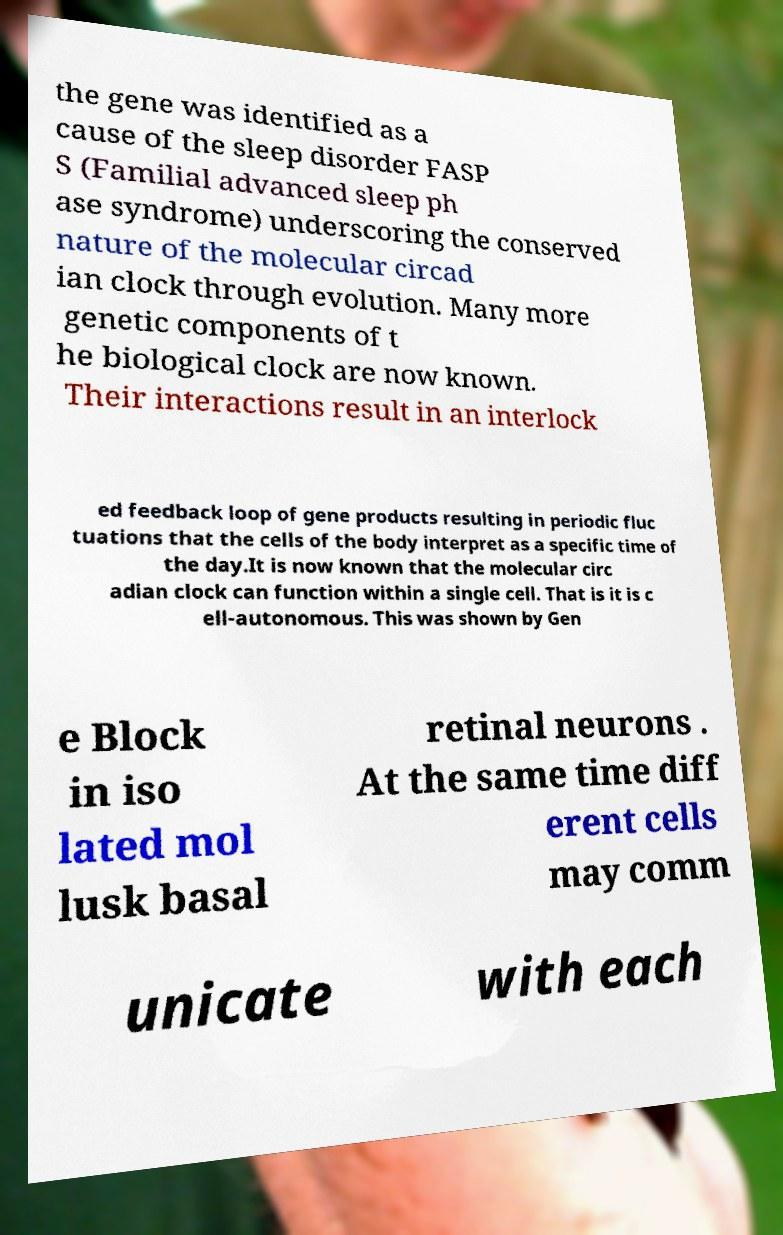Could you assist in decoding the text presented in this image and type it out clearly? the gene was identified as a cause of the sleep disorder FASP S (Familial advanced sleep ph ase syndrome) underscoring the conserved nature of the molecular circad ian clock through evolution. Many more genetic components of t he biological clock are now known. Their interactions result in an interlock ed feedback loop of gene products resulting in periodic fluc tuations that the cells of the body interpret as a specific time of the day.It is now known that the molecular circ adian clock can function within a single cell. That is it is c ell-autonomous. This was shown by Gen e Block in iso lated mol lusk basal retinal neurons . At the same time diff erent cells may comm unicate with each 